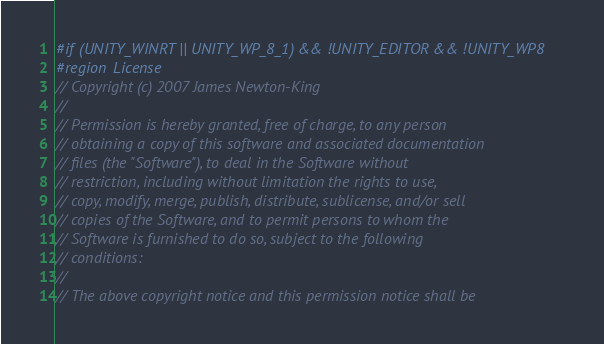Convert code to text. <code><loc_0><loc_0><loc_500><loc_500><_C#_>#if (UNITY_WINRT || UNITY_WP_8_1) && !UNITY_EDITOR && !UNITY_WP8
#region License
// Copyright (c) 2007 James Newton-King
//
// Permission is hereby granted, free of charge, to any person
// obtaining a copy of this software and associated documentation
// files (the "Software"), to deal in the Software without
// restriction, including without limitation the rights to use,
// copy, modify, merge, publish, distribute, sublicense, and/or sell
// copies of the Software, and to permit persons to whom the
// Software is furnished to do so, subject to the following
// conditions:
//
// The above copyright notice and this permission notice shall be</code> 